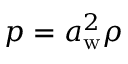Convert formula to latex. <formula><loc_0><loc_0><loc_500><loc_500>p = a _ { w } ^ { 2 } \rho</formula> 